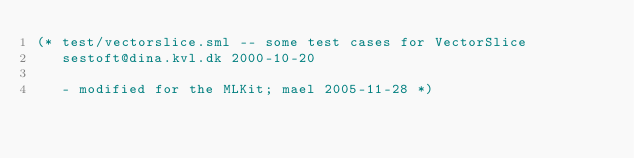<code> <loc_0><loc_0><loc_500><loc_500><_SML_>(* test/vectorslice.sml -- some test cases for VectorSlice 
   sestoft@dina.kvl.dk 2000-10-20 

   - modified for the MLKit; mael 2005-11-28 *)
</code> 